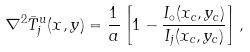<formula> <loc_0><loc_0><loc_500><loc_500>\nabla ^ { 2 } \bar { T } _ { j } ^ { u } ( x , y ) = \frac { 1 } { a } \left [ 1 - \frac { I _ { \circ } ( x _ { c } , y _ { c } ) } { I _ { j } ( x _ { c } , y _ { c } ) } \right ] ,</formula> 